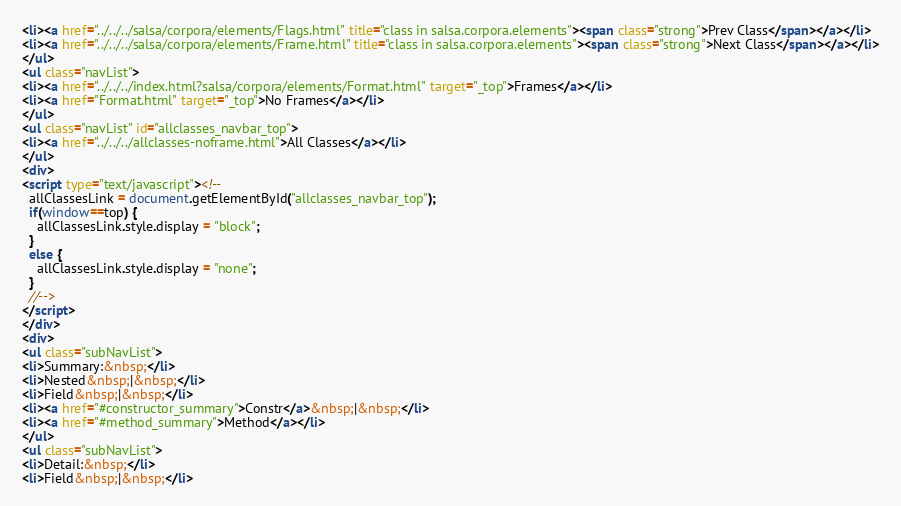Convert code to text. <code><loc_0><loc_0><loc_500><loc_500><_HTML_><li><a href="../../../salsa/corpora/elements/Flags.html" title="class in salsa.corpora.elements"><span class="strong">Prev Class</span></a></li>
<li><a href="../../../salsa/corpora/elements/Frame.html" title="class in salsa.corpora.elements"><span class="strong">Next Class</span></a></li>
</ul>
<ul class="navList">
<li><a href="../../../index.html?salsa/corpora/elements/Format.html" target="_top">Frames</a></li>
<li><a href="Format.html" target="_top">No Frames</a></li>
</ul>
<ul class="navList" id="allclasses_navbar_top">
<li><a href="../../../allclasses-noframe.html">All Classes</a></li>
</ul>
<div>
<script type="text/javascript"><!--
  allClassesLink = document.getElementById("allclasses_navbar_top");
  if(window==top) {
    allClassesLink.style.display = "block";
  }
  else {
    allClassesLink.style.display = "none";
  }
  //-->
</script>
</div>
<div>
<ul class="subNavList">
<li>Summary:&nbsp;</li>
<li>Nested&nbsp;|&nbsp;</li>
<li>Field&nbsp;|&nbsp;</li>
<li><a href="#constructor_summary">Constr</a>&nbsp;|&nbsp;</li>
<li><a href="#method_summary">Method</a></li>
</ul>
<ul class="subNavList">
<li>Detail:&nbsp;</li>
<li>Field&nbsp;|&nbsp;</li></code> 